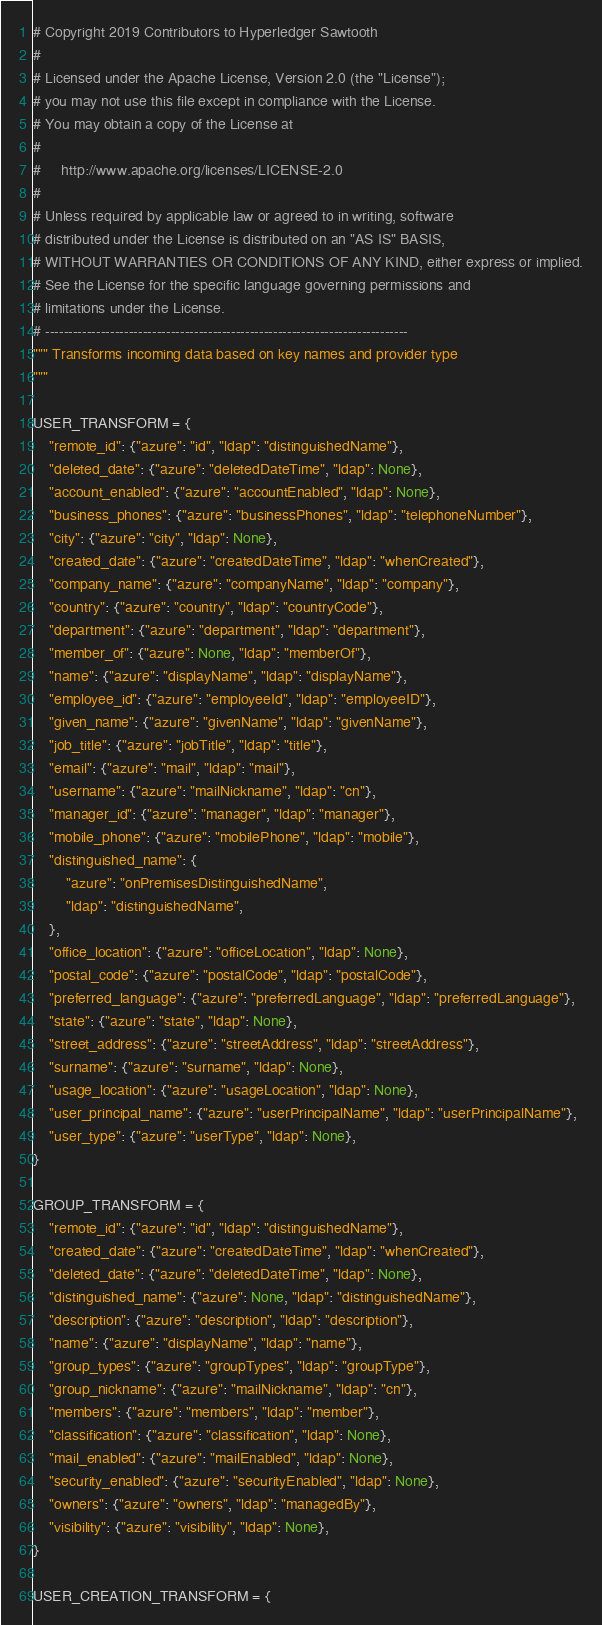<code> <loc_0><loc_0><loc_500><loc_500><_Python_># Copyright 2019 Contributors to Hyperledger Sawtooth
#
# Licensed under the Apache License, Version 2.0 (the "License");
# you may not use this file except in compliance with the License.
# You may obtain a copy of the License at
#
#     http://www.apache.org/licenses/LICENSE-2.0
#
# Unless required by applicable law or agreed to in writing, software
# distributed under the License is distributed on an "AS IS" BASIS,
# WITHOUT WARRANTIES OR CONDITIONS OF ANY KIND, either express or implied.
# See the License for the specific language governing permissions and
# limitations under the License.
# ------------------------------------------------------------------------------
""" Transforms incoming data based on key names and provider type
"""

USER_TRANSFORM = {
    "remote_id": {"azure": "id", "ldap": "distinguishedName"},
    "deleted_date": {"azure": "deletedDateTime", "ldap": None},
    "account_enabled": {"azure": "accountEnabled", "ldap": None},
    "business_phones": {"azure": "businessPhones", "ldap": "telephoneNumber"},
    "city": {"azure": "city", "ldap": None},
    "created_date": {"azure": "createdDateTime", "ldap": "whenCreated"},
    "company_name": {"azure": "companyName", "ldap": "company"},
    "country": {"azure": "country", "ldap": "countryCode"},
    "department": {"azure": "department", "ldap": "department"},
    "member_of": {"azure": None, "ldap": "memberOf"},
    "name": {"azure": "displayName", "ldap": "displayName"},
    "employee_id": {"azure": "employeeId", "ldap": "employeeID"},
    "given_name": {"azure": "givenName", "ldap": "givenName"},
    "job_title": {"azure": "jobTitle", "ldap": "title"},
    "email": {"azure": "mail", "ldap": "mail"},
    "username": {"azure": "mailNickname", "ldap": "cn"},
    "manager_id": {"azure": "manager", "ldap": "manager"},
    "mobile_phone": {"azure": "mobilePhone", "ldap": "mobile"},
    "distinguished_name": {
        "azure": "onPremisesDistinguishedName",
        "ldap": "distinguishedName",
    },
    "office_location": {"azure": "officeLocation", "ldap": None},
    "postal_code": {"azure": "postalCode", "ldap": "postalCode"},
    "preferred_language": {"azure": "preferredLanguage", "ldap": "preferredLanguage"},
    "state": {"azure": "state", "ldap": None},
    "street_address": {"azure": "streetAddress", "ldap": "streetAddress"},
    "surname": {"azure": "surname", "ldap": None},
    "usage_location": {"azure": "usageLocation", "ldap": None},
    "user_principal_name": {"azure": "userPrincipalName", "ldap": "userPrincipalName"},
    "user_type": {"azure": "userType", "ldap": None},
}

GROUP_TRANSFORM = {
    "remote_id": {"azure": "id", "ldap": "distinguishedName"},
    "created_date": {"azure": "createdDateTime", "ldap": "whenCreated"},
    "deleted_date": {"azure": "deletedDateTime", "ldap": None},
    "distinguished_name": {"azure": None, "ldap": "distinguishedName"},
    "description": {"azure": "description", "ldap": "description"},
    "name": {"azure": "displayName", "ldap": "name"},
    "group_types": {"azure": "groupTypes", "ldap": "groupType"},
    "group_nickname": {"azure": "mailNickname", "ldap": "cn"},
    "members": {"azure": "members", "ldap": "member"},
    "classification": {"azure": "classification", "ldap": None},
    "mail_enabled": {"azure": "mailEnabled", "ldap": None},
    "security_enabled": {"azure": "securityEnabled", "ldap": None},
    "owners": {"azure": "owners", "ldap": "managedBy"},
    "visibility": {"azure": "visibility", "ldap": None},
}

USER_CREATION_TRANSFORM = {</code> 